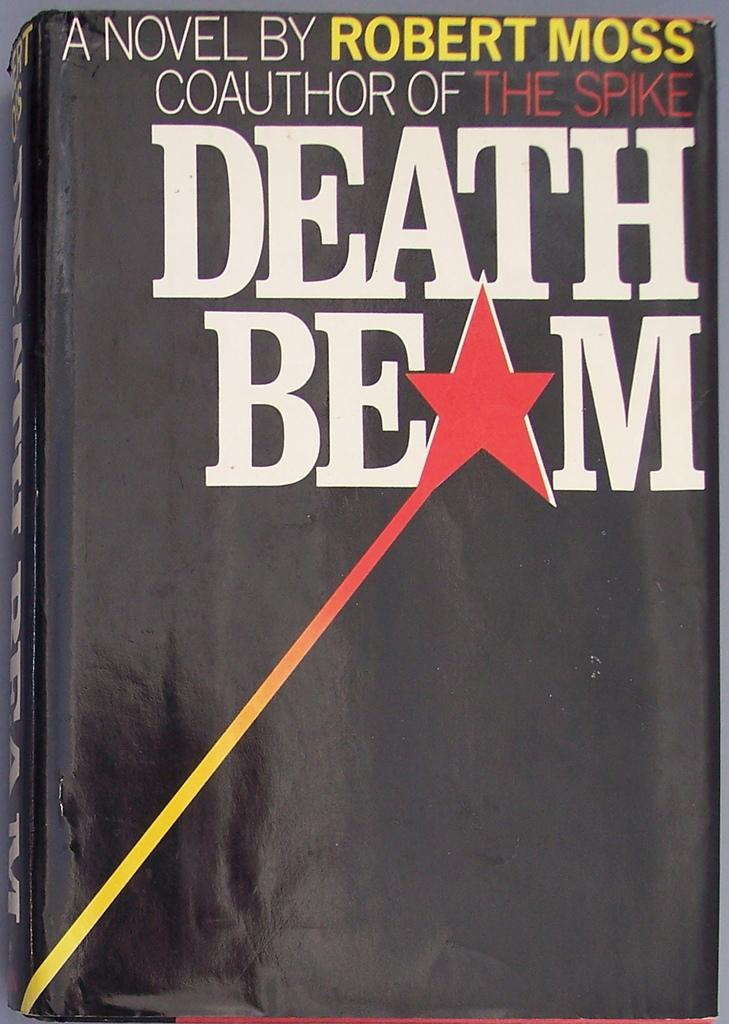What is the main object in the image? The main object in the image is a book. What color is the book? The book is black in color. What can be found on the book? There is text written on the book. Are there any distinguishing marks on the book? Yes, there is a star mark on the book. How many children are playing with the book in the image? There are no children present in the image; it only features a book with text and a star mark. 